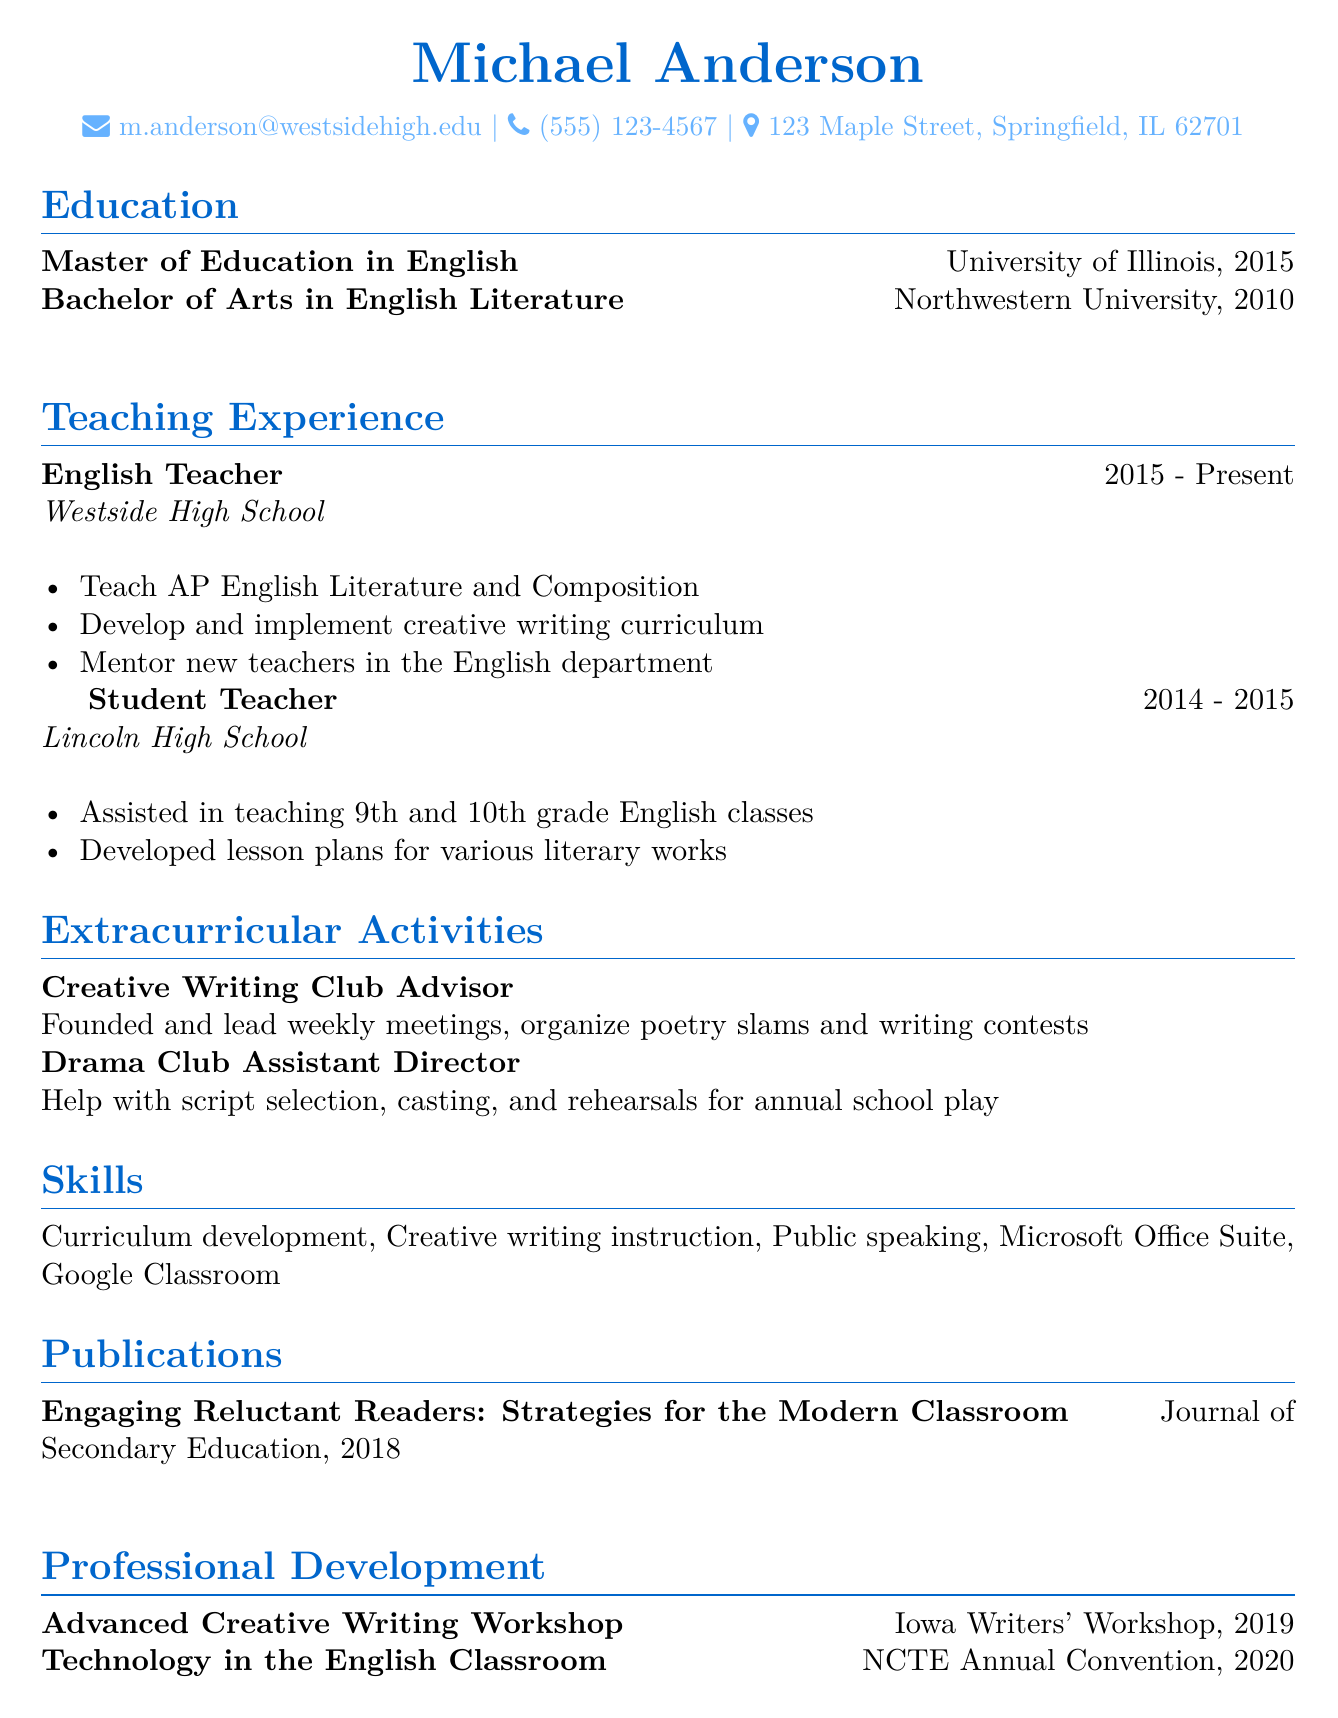what is the name of the individual? The name is presented at the top of the CV under the personal information section.
Answer: Michael Anderson what degree did Michael Anderson earn in 2015? This information is found in the education section, indicating the most recent degree earned.
Answer: Master of Education in English which school has Michael been teaching at since 2015? The teaching experience section lists the current school where he is employed.
Answer: Westside High School what is one of Michael's responsibilities as an English Teacher? This is outlined in the teaching experience section, showing key duties of the position.
Answer: Develop and implement creative writing curriculum how many years did Michael work as a Student Teacher? The duration is specified in the teaching experience, showing the timeline of this role.
Answer: 1 year what extracurricular activity does Michael advise? The activities section details his involvement outside of classroom teaching.
Answer: Creative Writing Club what publication did Michael contribute to in 2018? This answer can be found in the publications section of the CV.
Answer: Engaging Reluctant Readers: Strategies for the Modern Classroom which workshop did Michael attend in 2019? Professional development courses list his learning experiences beyond formal education.
Answer: Advanced Creative Writing Workshop what skill related to technology is mentioned in Michael's CV? This skill is mentioned among the skills section, indicating his proficiency in educational tools.
Answer: Google Classroom 